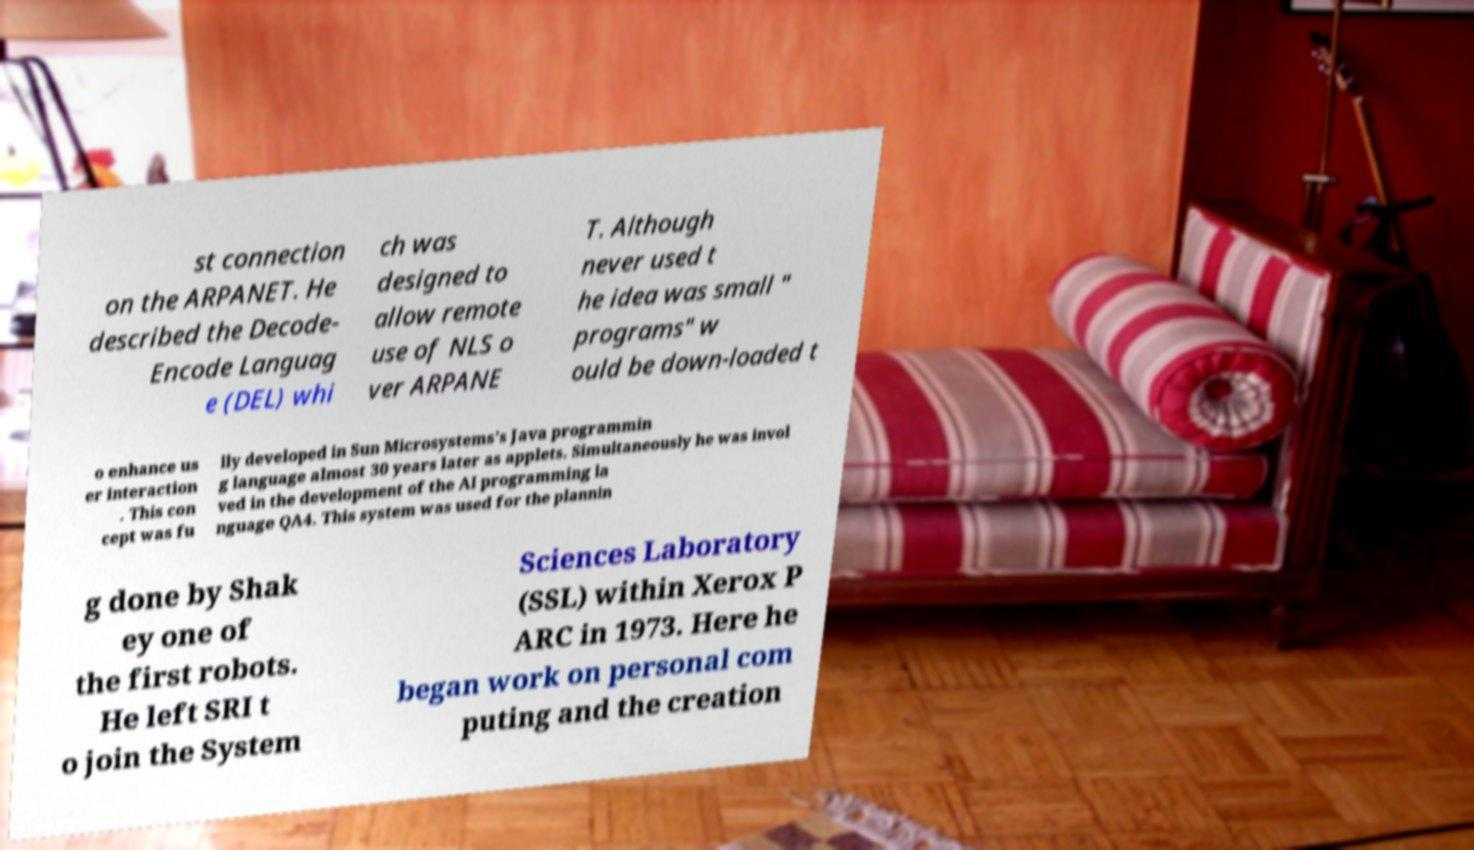Can you read and provide the text displayed in the image?This photo seems to have some interesting text. Can you extract and type it out for me? st connection on the ARPANET. He described the Decode- Encode Languag e (DEL) whi ch was designed to allow remote use of NLS o ver ARPANE T. Although never used t he idea was small " programs" w ould be down-loaded t o enhance us er interaction . This con cept was fu lly developed in Sun Microsystems's Java programmin g language almost 30 years later as applets. Simultaneously he was invol ved in the development of the AI programming la nguage QA4. This system was used for the plannin g done by Shak ey one of the first robots. He left SRI t o join the System Sciences Laboratory (SSL) within Xerox P ARC in 1973. Here he began work on personal com puting and the creation 